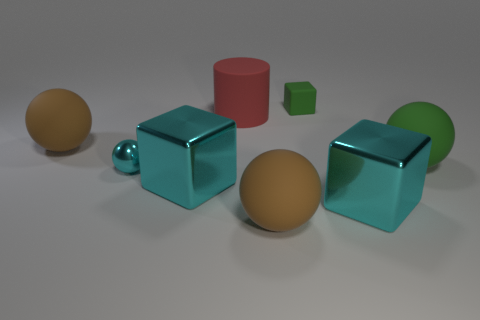What number of tiny objects are red rubber objects or green rubber balls?
Your response must be concise. 0. Are there fewer cyan blocks that are right of the large red rubber object than green matte blocks that are in front of the tiny green cube?
Provide a short and direct response. No. How many things are either tiny cyan objects or big cyan metallic things?
Your response must be concise. 3. What number of large brown rubber spheres are behind the green sphere?
Your response must be concise. 1. Is the color of the tiny matte cube the same as the tiny metallic thing?
Your response must be concise. No. The tiny thing that is the same material as the green ball is what shape?
Ensure brevity in your answer.  Cube. There is a brown object that is on the right side of the shiny sphere; is it the same shape as the tiny cyan metal thing?
Provide a short and direct response. Yes. How many red objects are rubber cubes or rubber objects?
Provide a succinct answer. 1. Are there the same number of big rubber cylinders in front of the large green sphere and large cyan cubes behind the tiny cyan thing?
Make the answer very short. Yes. What is the color of the block behind the large brown rubber ball behind the big rubber ball in front of the green matte ball?
Provide a succinct answer. Green. 